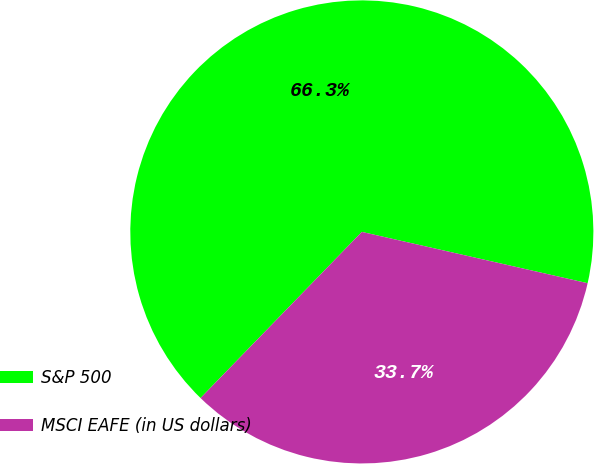Convert chart to OTSL. <chart><loc_0><loc_0><loc_500><loc_500><pie_chart><fcel>S&P 500<fcel>MSCI EAFE (in US dollars)<nl><fcel>66.29%<fcel>33.71%<nl></chart> 